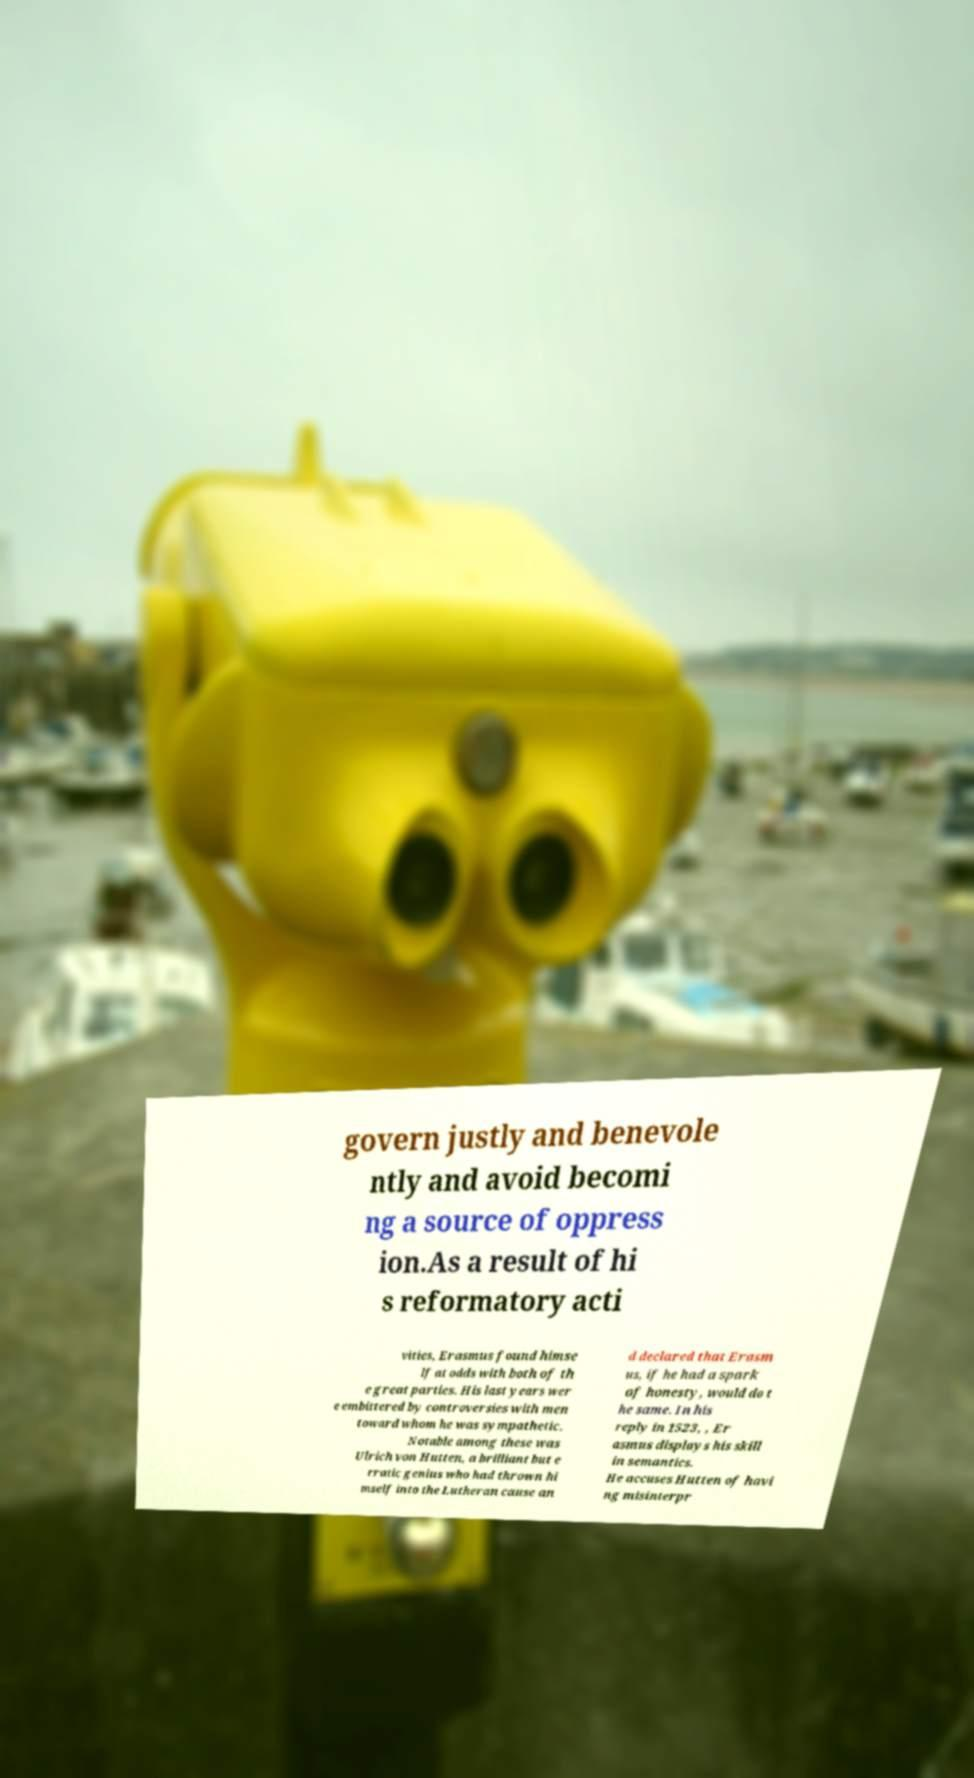Please identify and transcribe the text found in this image. govern justly and benevole ntly and avoid becomi ng a source of oppress ion.As a result of hi s reformatory acti vities, Erasmus found himse lf at odds with both of th e great parties. His last years wer e embittered by controversies with men toward whom he was sympathetic. Notable among these was Ulrich von Hutten, a brilliant but e rratic genius who had thrown hi mself into the Lutheran cause an d declared that Erasm us, if he had a spark of honesty, would do t he same. In his reply in 1523, , Er asmus displays his skill in semantics. He accuses Hutten of havi ng misinterpr 